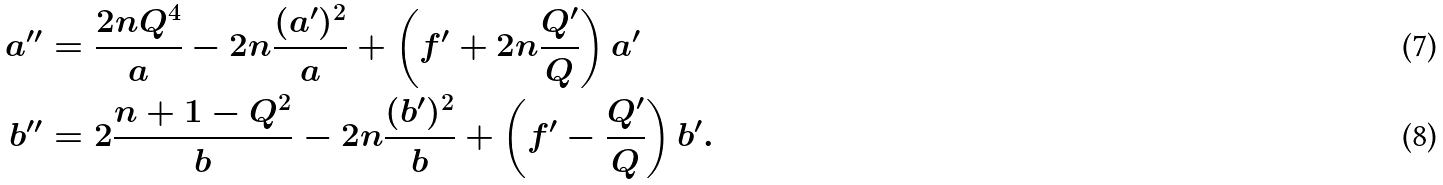Convert formula to latex. <formula><loc_0><loc_0><loc_500><loc_500>a ^ { \prime \prime } & = \frac { 2 n Q ^ { 4 } } { a } - 2 n \frac { ( a ^ { \prime } ) ^ { 2 } } { a } + \left ( f ^ { \prime } + 2 n \frac { Q ^ { \prime } } { Q } \right ) a ^ { \prime } \\ b ^ { \prime \prime } & = 2 \frac { n + 1 - Q ^ { 2 } } { b } - 2 n \frac { ( b ^ { \prime } ) ^ { 2 } } { b } + \left ( f ^ { \prime } - \frac { Q ^ { \prime } } { Q } \right ) b ^ { \prime } .</formula> 